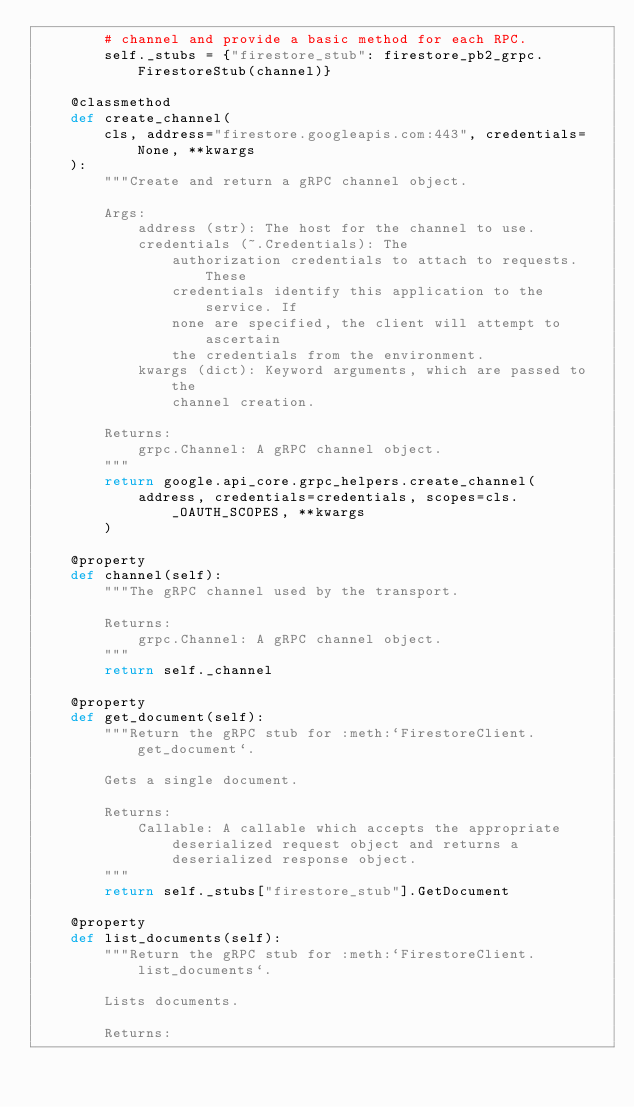Convert code to text. <code><loc_0><loc_0><loc_500><loc_500><_Python_>        # channel and provide a basic method for each RPC.
        self._stubs = {"firestore_stub": firestore_pb2_grpc.FirestoreStub(channel)}

    @classmethod
    def create_channel(
        cls, address="firestore.googleapis.com:443", credentials=None, **kwargs
    ):
        """Create and return a gRPC channel object.

        Args:
            address (str): The host for the channel to use.
            credentials (~.Credentials): The
                authorization credentials to attach to requests. These
                credentials identify this application to the service. If
                none are specified, the client will attempt to ascertain
                the credentials from the environment.
            kwargs (dict): Keyword arguments, which are passed to the
                channel creation.

        Returns:
            grpc.Channel: A gRPC channel object.
        """
        return google.api_core.grpc_helpers.create_channel(
            address, credentials=credentials, scopes=cls._OAUTH_SCOPES, **kwargs
        )

    @property
    def channel(self):
        """The gRPC channel used by the transport.

        Returns:
            grpc.Channel: A gRPC channel object.
        """
        return self._channel

    @property
    def get_document(self):
        """Return the gRPC stub for :meth:`FirestoreClient.get_document`.

        Gets a single document.

        Returns:
            Callable: A callable which accepts the appropriate
                deserialized request object and returns a
                deserialized response object.
        """
        return self._stubs["firestore_stub"].GetDocument

    @property
    def list_documents(self):
        """Return the gRPC stub for :meth:`FirestoreClient.list_documents`.

        Lists documents.

        Returns:</code> 